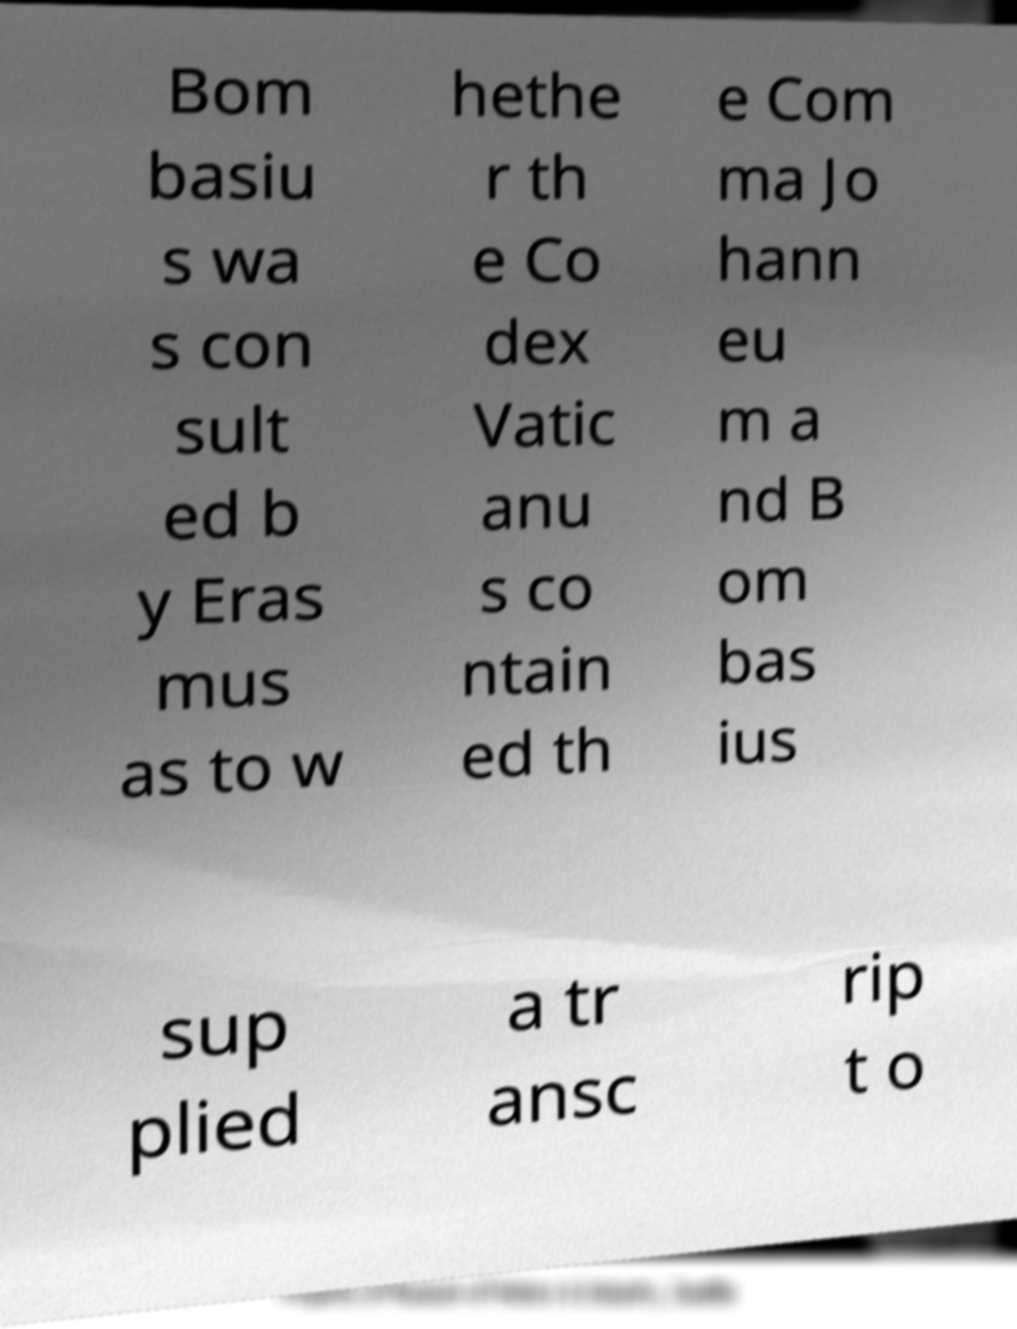There's text embedded in this image that I need extracted. Can you transcribe it verbatim? Bom basiu s wa s con sult ed b y Eras mus as to w hethe r th e Co dex Vatic anu s co ntain ed th e Com ma Jo hann eu m a nd B om bas ius sup plied a tr ansc rip t o 